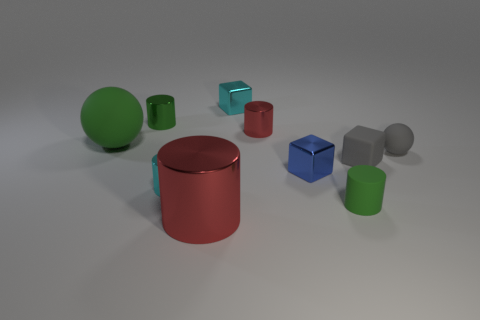What number of other objects are the same shape as the large metal object?
Make the answer very short. 4. Do the green metal object and the blue thing have the same size?
Ensure brevity in your answer.  Yes. Is there a large purple ball?
Make the answer very short. No. Are there any tiny red cylinders that have the same material as the blue object?
Offer a terse response. Yes. There is a red cylinder that is the same size as the green rubber ball; what is its material?
Provide a short and direct response. Metal. How many tiny rubber objects have the same shape as the big rubber thing?
Your response must be concise. 1. What is the size of the gray block that is made of the same material as the tiny gray ball?
Your response must be concise. Small. There is a object that is behind the large matte ball and to the left of the cyan metallic cylinder; what material is it?
Provide a succinct answer. Metal. How many metallic cylinders are the same size as the gray cube?
Your answer should be very brief. 3. What is the material of the big object that is the same shape as the small red shiny thing?
Offer a very short reply. Metal. 